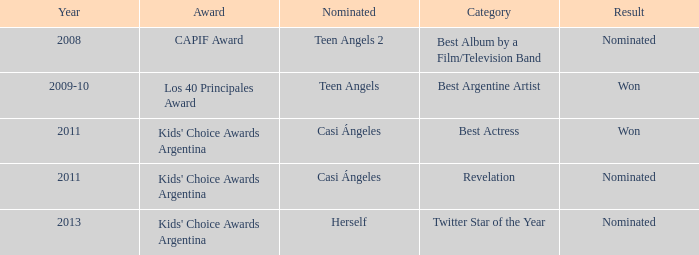Name the performance nominated for a Capif Award. Teen Angels 2. 